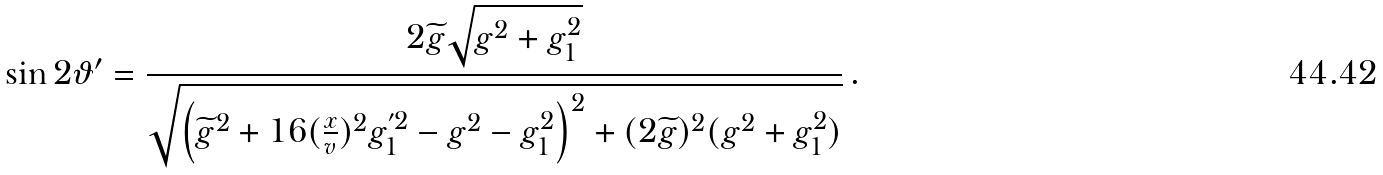<formula> <loc_0><loc_0><loc_500><loc_500>\sin { 2 \vartheta ^ { \prime } } = \frac { 2 \widetilde { g } \sqrt { g ^ { 2 } + g _ { 1 } ^ { 2 } } } { \sqrt { \left ( \widetilde { g } ^ { 2 } + 1 6 ( \frac { x } { v } ) ^ { 2 } g _ { 1 } ^ { ^ { \prime } 2 } - g ^ { 2 } - g _ { 1 } ^ { 2 } \right ) ^ { 2 } + ( 2 \widetilde { g } ) ^ { 2 } ( g ^ { 2 } + g _ { 1 } ^ { 2 } ) } } \, .</formula> 